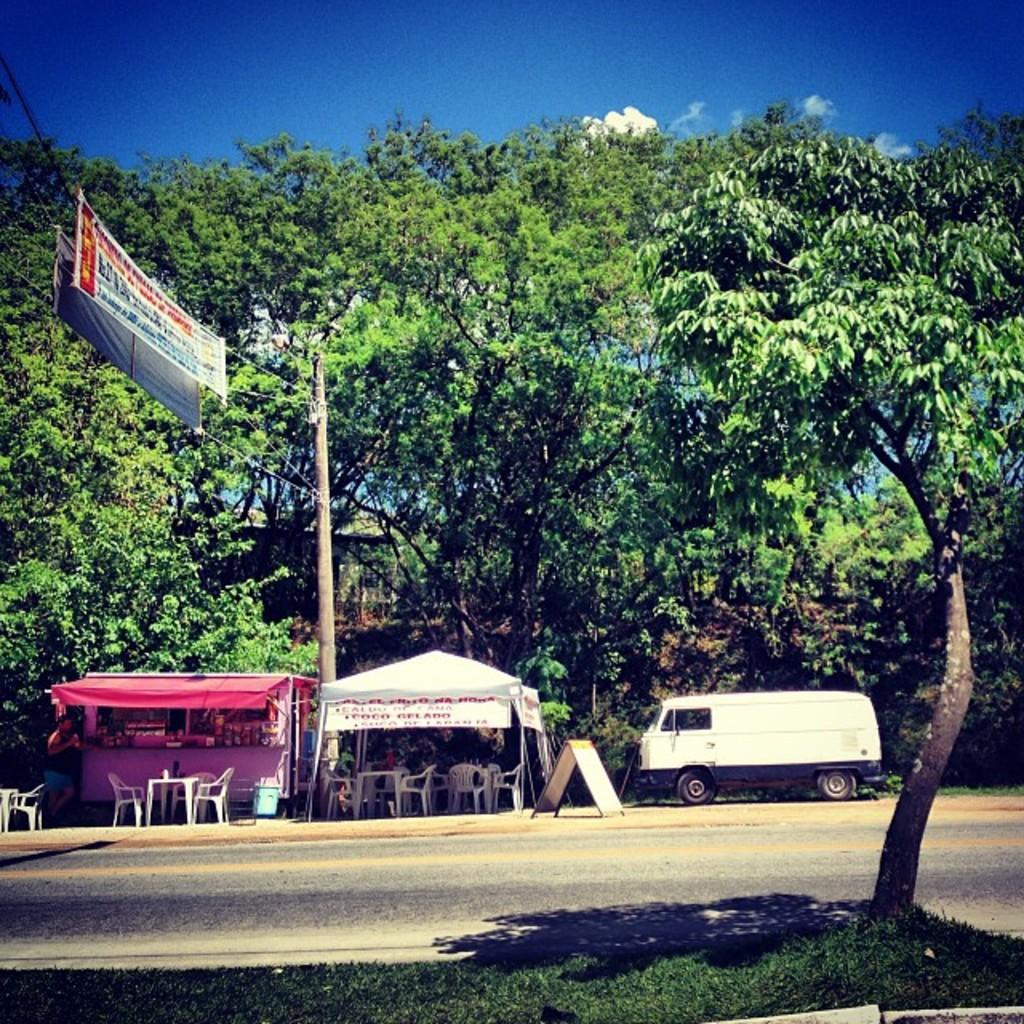How would you summarize this image in a sentence or two? In the picture we can see a part of the road and near it, we can see a tree on the grass surface and on the opposite side, we can see two stalls with tables and chairs and beside it, we can see a van which is white in color and behind it we can see some trees and on the top of it we can see the sky. 